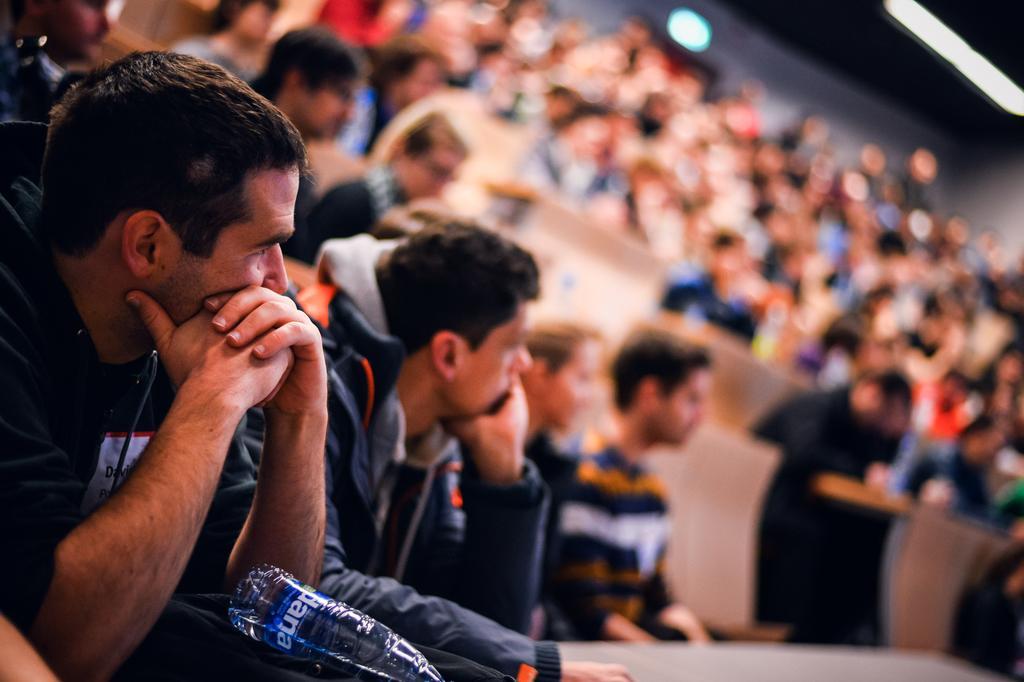In one or two sentences, can you explain what this image depicts? In this image in the foreground there are some people sitting and there is a bottle, and there is a blurry background. 